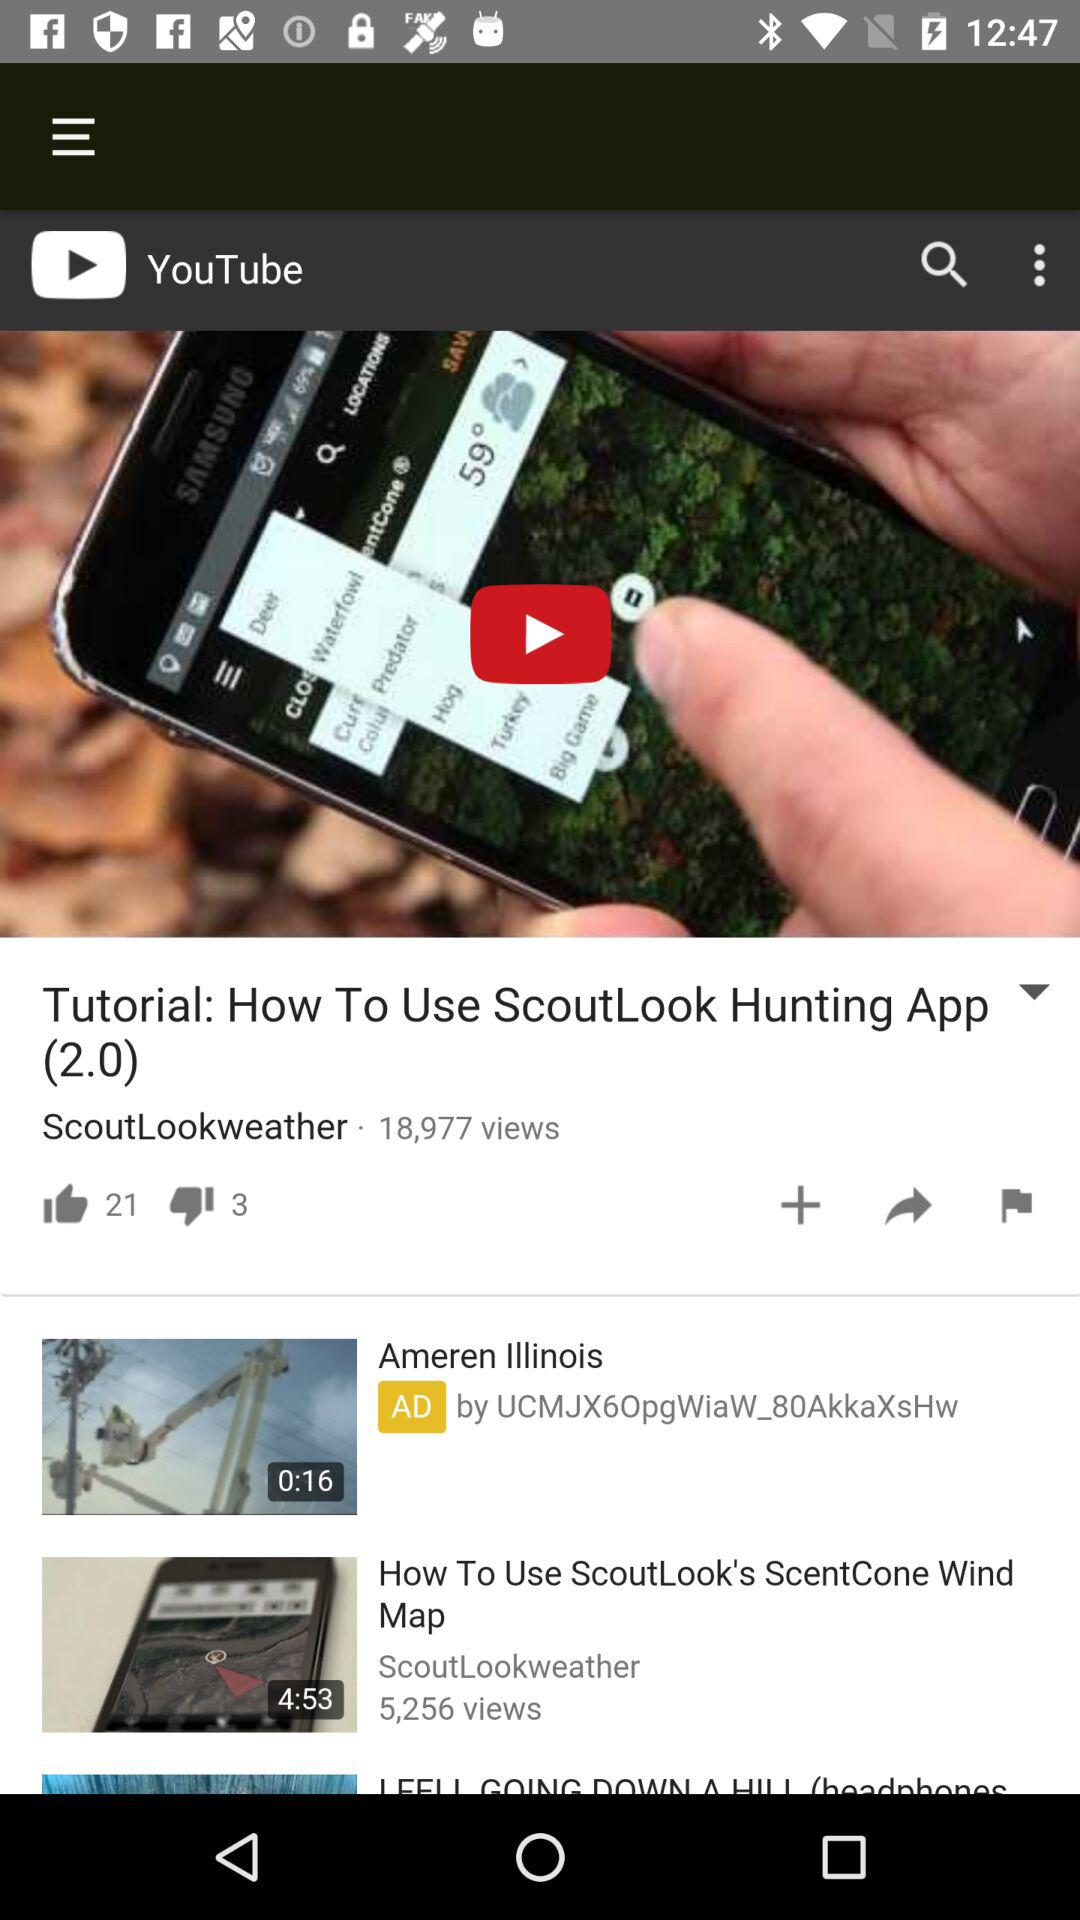Which version of "ScoutLook Hunting" application is shown? The shown version is 2.0. 